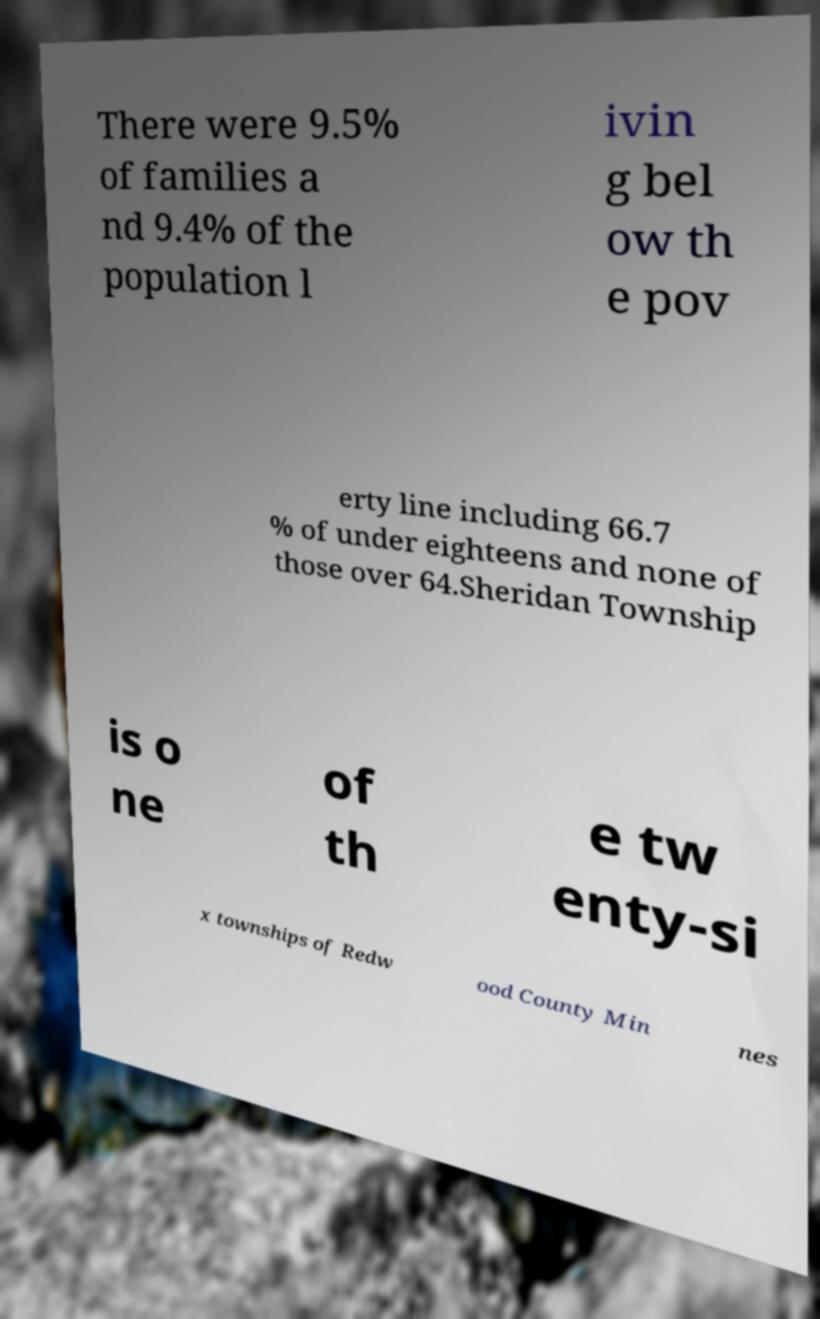What messages or text are displayed in this image? I need them in a readable, typed format. There were 9.5% of families a nd 9.4% of the population l ivin g bel ow th e pov erty line including 66.7 % of under eighteens and none of those over 64.Sheridan Township is o ne of th e tw enty-si x townships of Redw ood County Min nes 